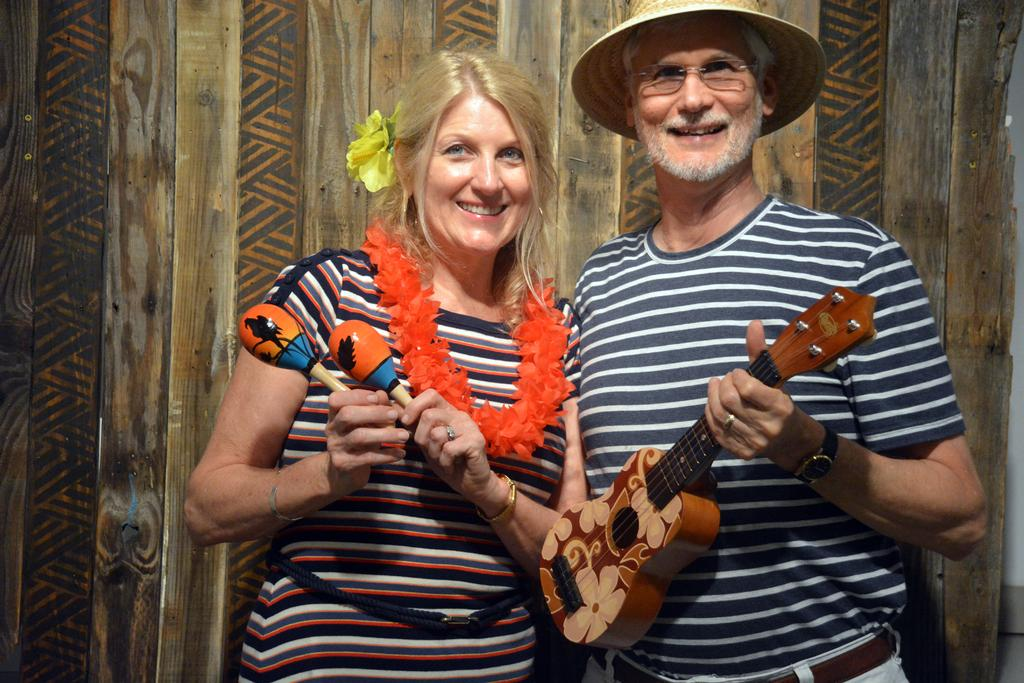How many people are in the image? There are two people in the image, a woman and a man. What are the woman and the man doing in the image? Both the woman and the man are holding musical instruments. What can be seen in the background of the image? There is a wooden wall in the background of the image. How does the air affect the musical instruments in the image? There is no information about the air in the image, so we cannot determine how it affects the musical instruments. 